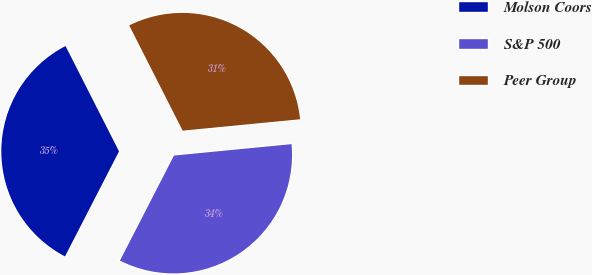Convert chart. <chart><loc_0><loc_0><loc_500><loc_500><pie_chart><fcel>Molson Coors<fcel>S&P 500<fcel>Peer Group<nl><fcel>34.96%<fcel>34.1%<fcel>30.94%<nl></chart> 